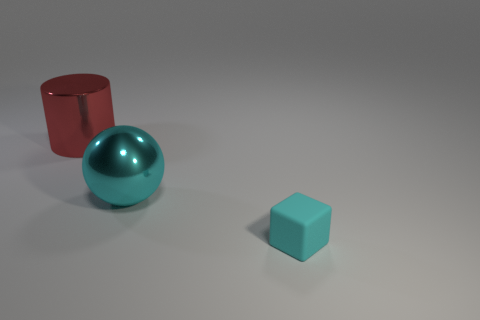Subtract all purple spheres. Subtract all large red cylinders. How many objects are left? 2 Add 2 large metallic things. How many large metallic things are left? 4 Add 2 tiny blue cylinders. How many tiny blue cylinders exist? 2 Add 2 big cylinders. How many objects exist? 5 Subtract 1 cyan balls. How many objects are left? 2 Subtract all cylinders. How many objects are left? 2 Subtract all yellow cylinders. Subtract all cyan cubes. How many cylinders are left? 1 Subtract all brown cylinders. How many green balls are left? 0 